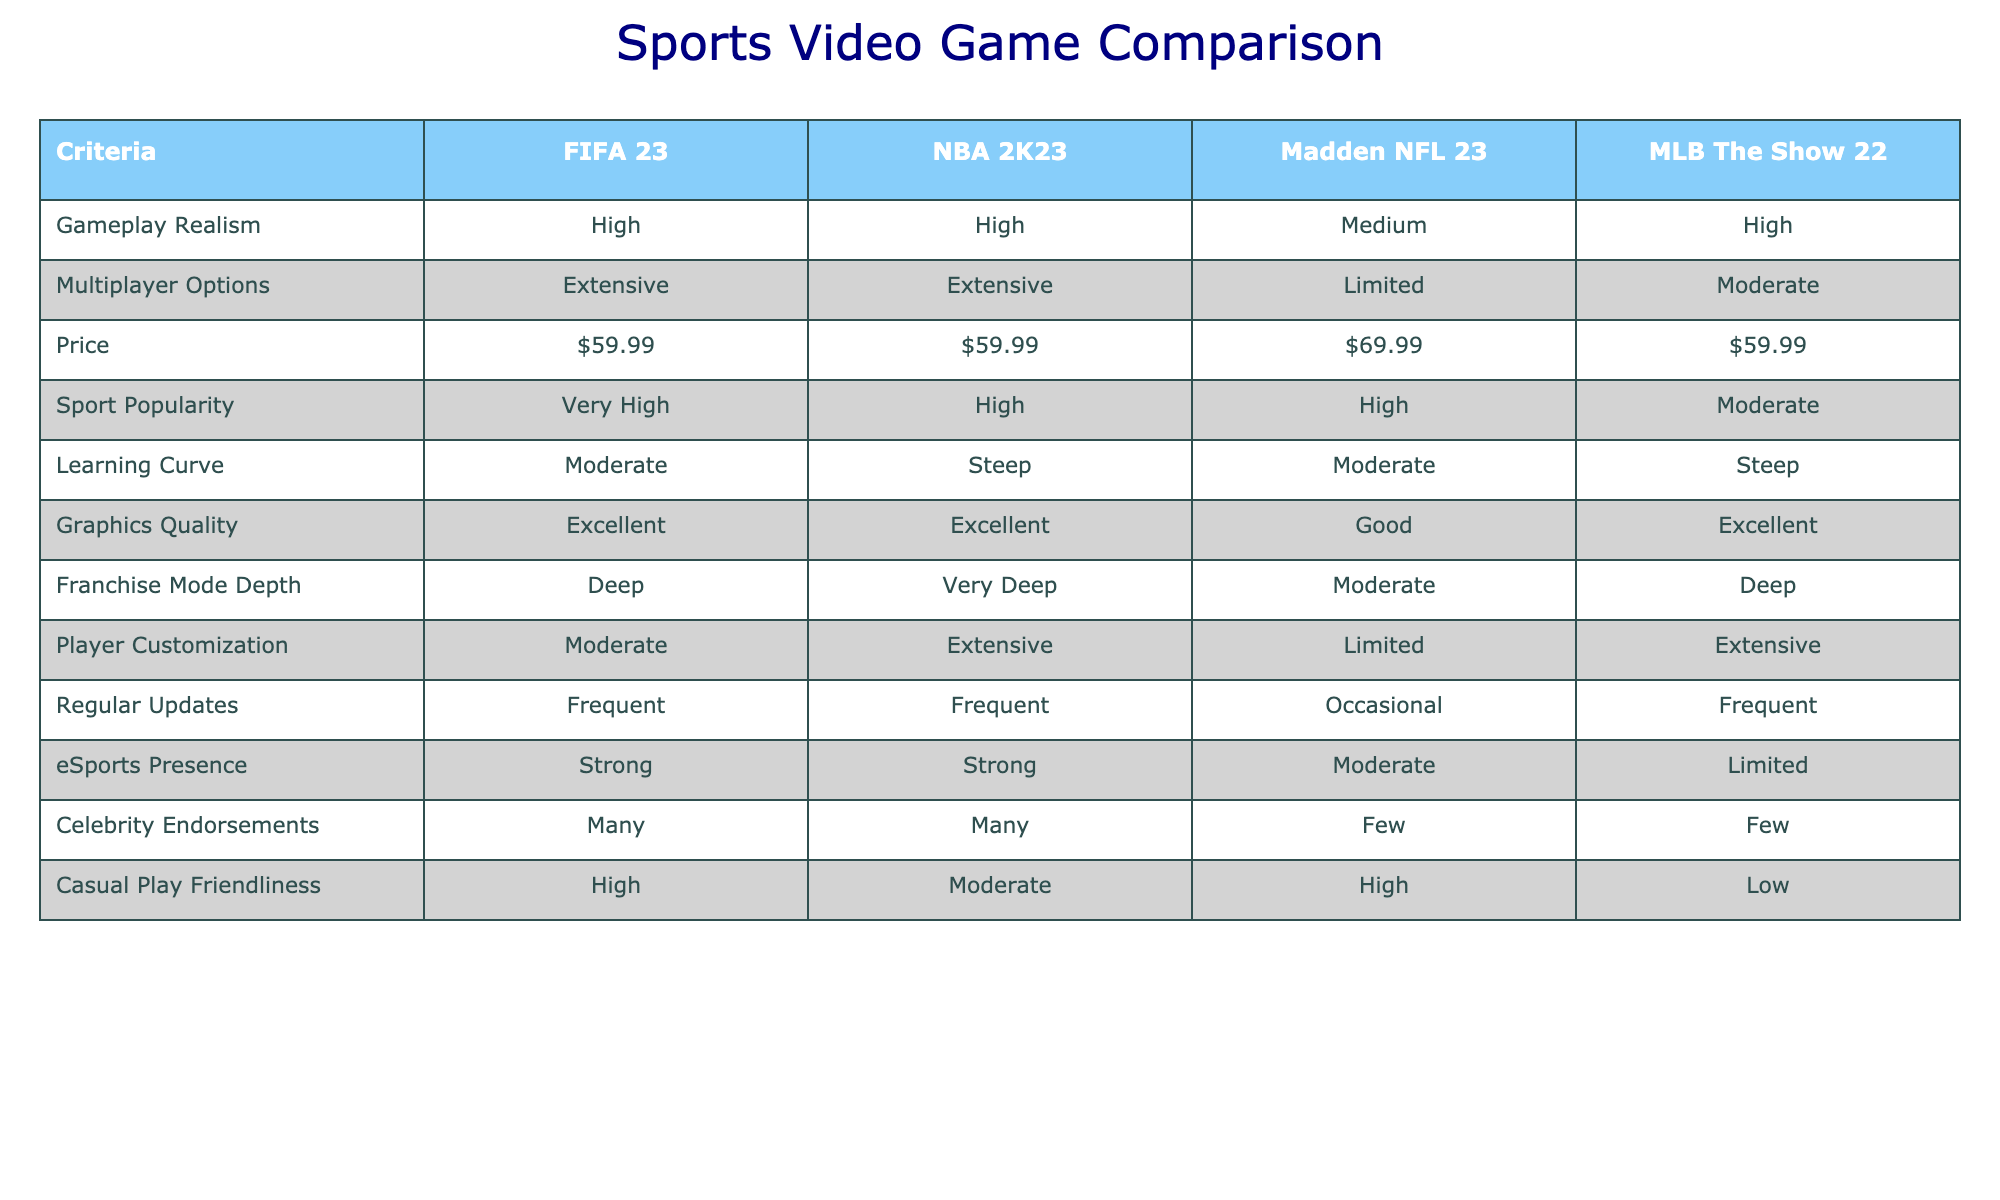What is the price of FIFA 23? The table shows that FIFA 23 is listed at $59.99 under the Price column.
Answer: $59.99 Which game has the highest learning curve? By examining the Learning Curve row, NBA 2K23 and MLB The Show 22 are noted as steep, which is higher than FIFA 23 and Madden NFL 23, which are marked as moderate. Therefore, both NBA 2K23 and MLB The Show 22 share the highest learning curve classification.
Answer: NBA 2K23 and MLB The Show 22 Is the multiplayer option for Madden NFL 23 extensive? In the Multiplayer Options row, Madden NFL 23 is categorized as limited. So it does not have extensive multiplayer options.
Answer: No What is the average gameplay realism rating for the four games? Looking at the gameplay realism ratings for the games: FIFA 23 (High), NBA 2K23 (High), Madden NFL 23 (Medium), and MLB The Show 22 (High), two games are rated high, one is medium. Assigning values: High=3, Medium=2 gives a total of (3 + 3 + 2 + 3) = 11. There are four games, so the average is 11 / 4 = 2.75. We classify gameplay realism ratings as High (3), Medium (2), or Low (1) and find that the average falls between Medium and High, but closer to High. Therefore, we can summarize that the average gameplay realism rating is Medium to High.
Answer: Between Medium and High (2.75) Which game has the best franchise mode depth? The table indicates that NBA 2K23 has the designation of "Very Deep" for Franchise Mode Depth, surpassing the other games, which are rated as Deep (FIFA 23, MLB The Show 22) and Moderate (Madden NFL 23).
Answer: NBA 2K23 